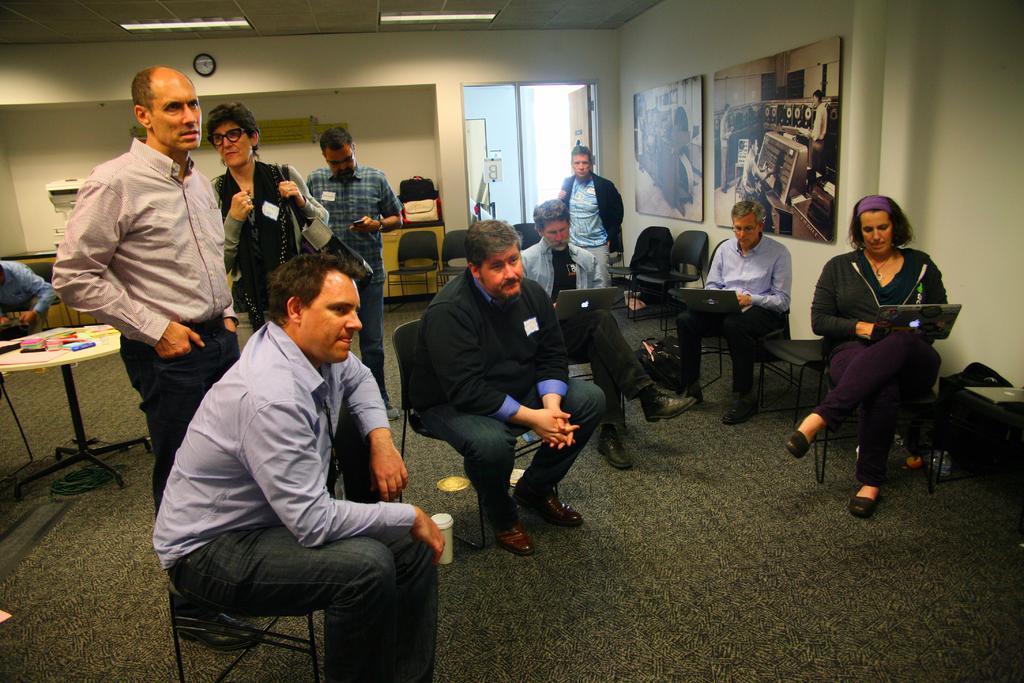Could you give a brief overview of what you see in this image? In the picture I can see people among them some are standing on the floor and some are sitting on chair. I can also see some of them are holding laptops. In the background I can see a table, chairs, a door, lights on the ceiling and some other objects. 